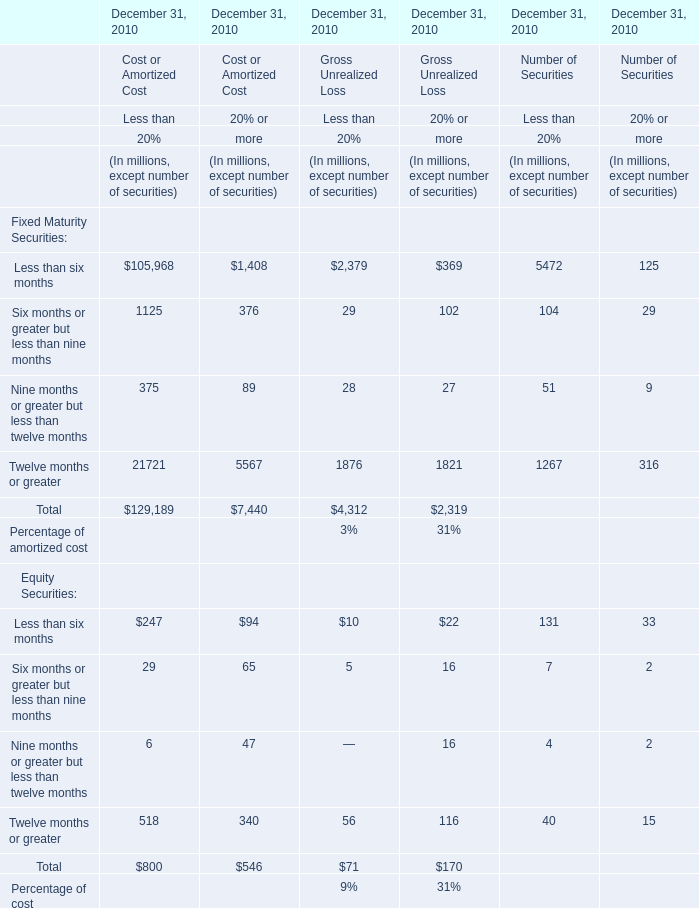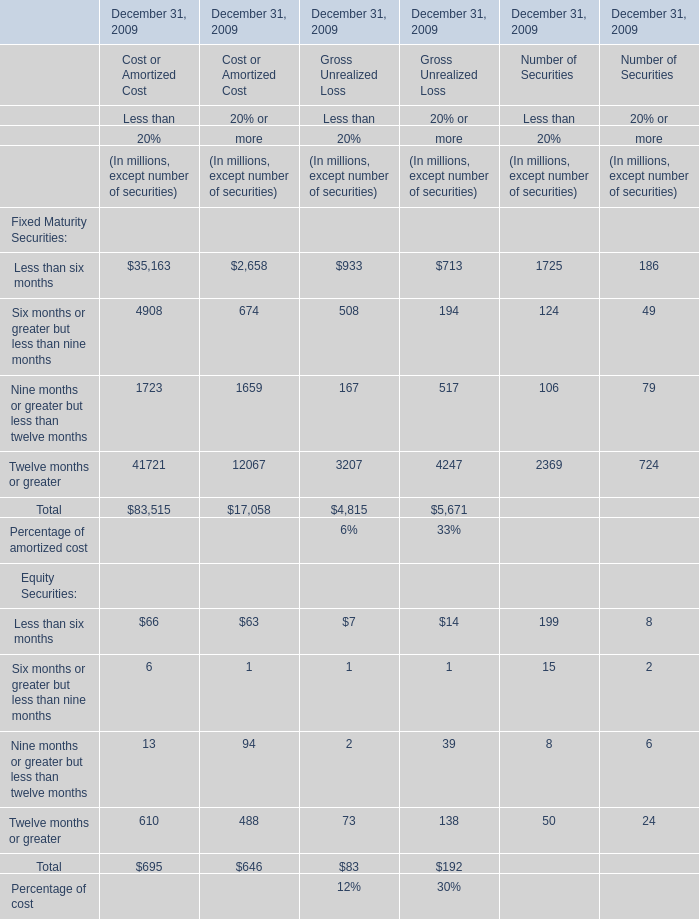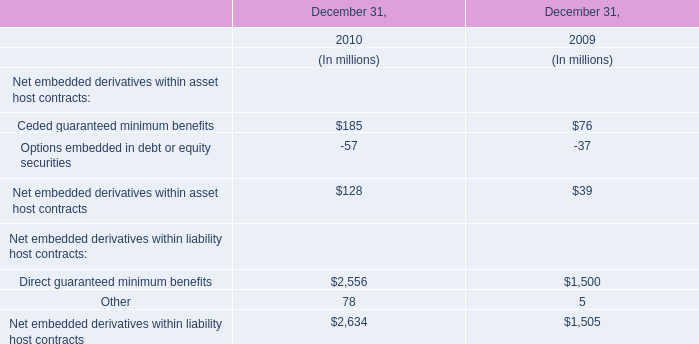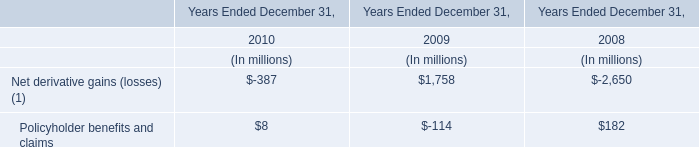What's the greatest value of the Gross Unrealized Loss in terms of Less than 20% at December 31, 2010? (in million) 
Answer: 4312. 